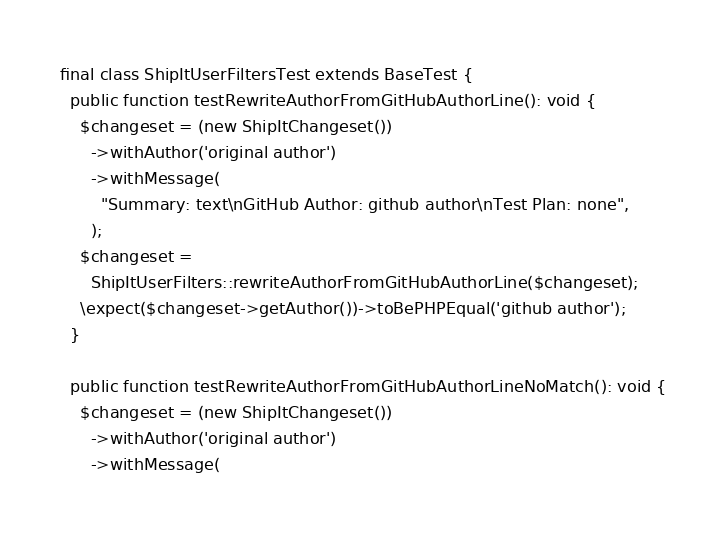Convert code to text. <code><loc_0><loc_0><loc_500><loc_500><_PHP_>final class ShipItUserFiltersTest extends BaseTest {
  public function testRewriteAuthorFromGitHubAuthorLine(): void {
    $changeset = (new ShipItChangeset())
      ->withAuthor('original author')
      ->withMessage(
        "Summary: text\nGitHub Author: github author\nTest Plan: none",
      );
    $changeset =
      ShipItUserFilters::rewriteAuthorFromGitHubAuthorLine($changeset);
    \expect($changeset->getAuthor())->toBePHPEqual('github author');
  }

  public function testRewriteAuthorFromGitHubAuthorLineNoMatch(): void {
    $changeset = (new ShipItChangeset())
      ->withAuthor('original author')
      ->withMessage(</code> 